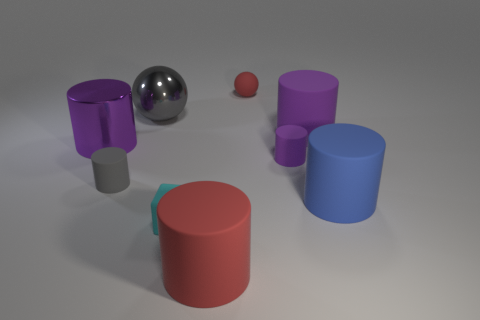Subtract all red blocks. How many purple cylinders are left? 3 Subtract all big red rubber cylinders. How many cylinders are left? 5 Subtract all blue cylinders. How many cylinders are left? 5 Subtract all gray cylinders. Subtract all cyan spheres. How many cylinders are left? 5 Subtract all spheres. How many objects are left? 7 Add 7 big yellow metal spheres. How many big yellow metal spheres exist? 7 Subtract 0 gray cubes. How many objects are left? 9 Subtract all small purple rubber objects. Subtract all gray rubber objects. How many objects are left? 7 Add 1 small purple cylinders. How many small purple cylinders are left? 2 